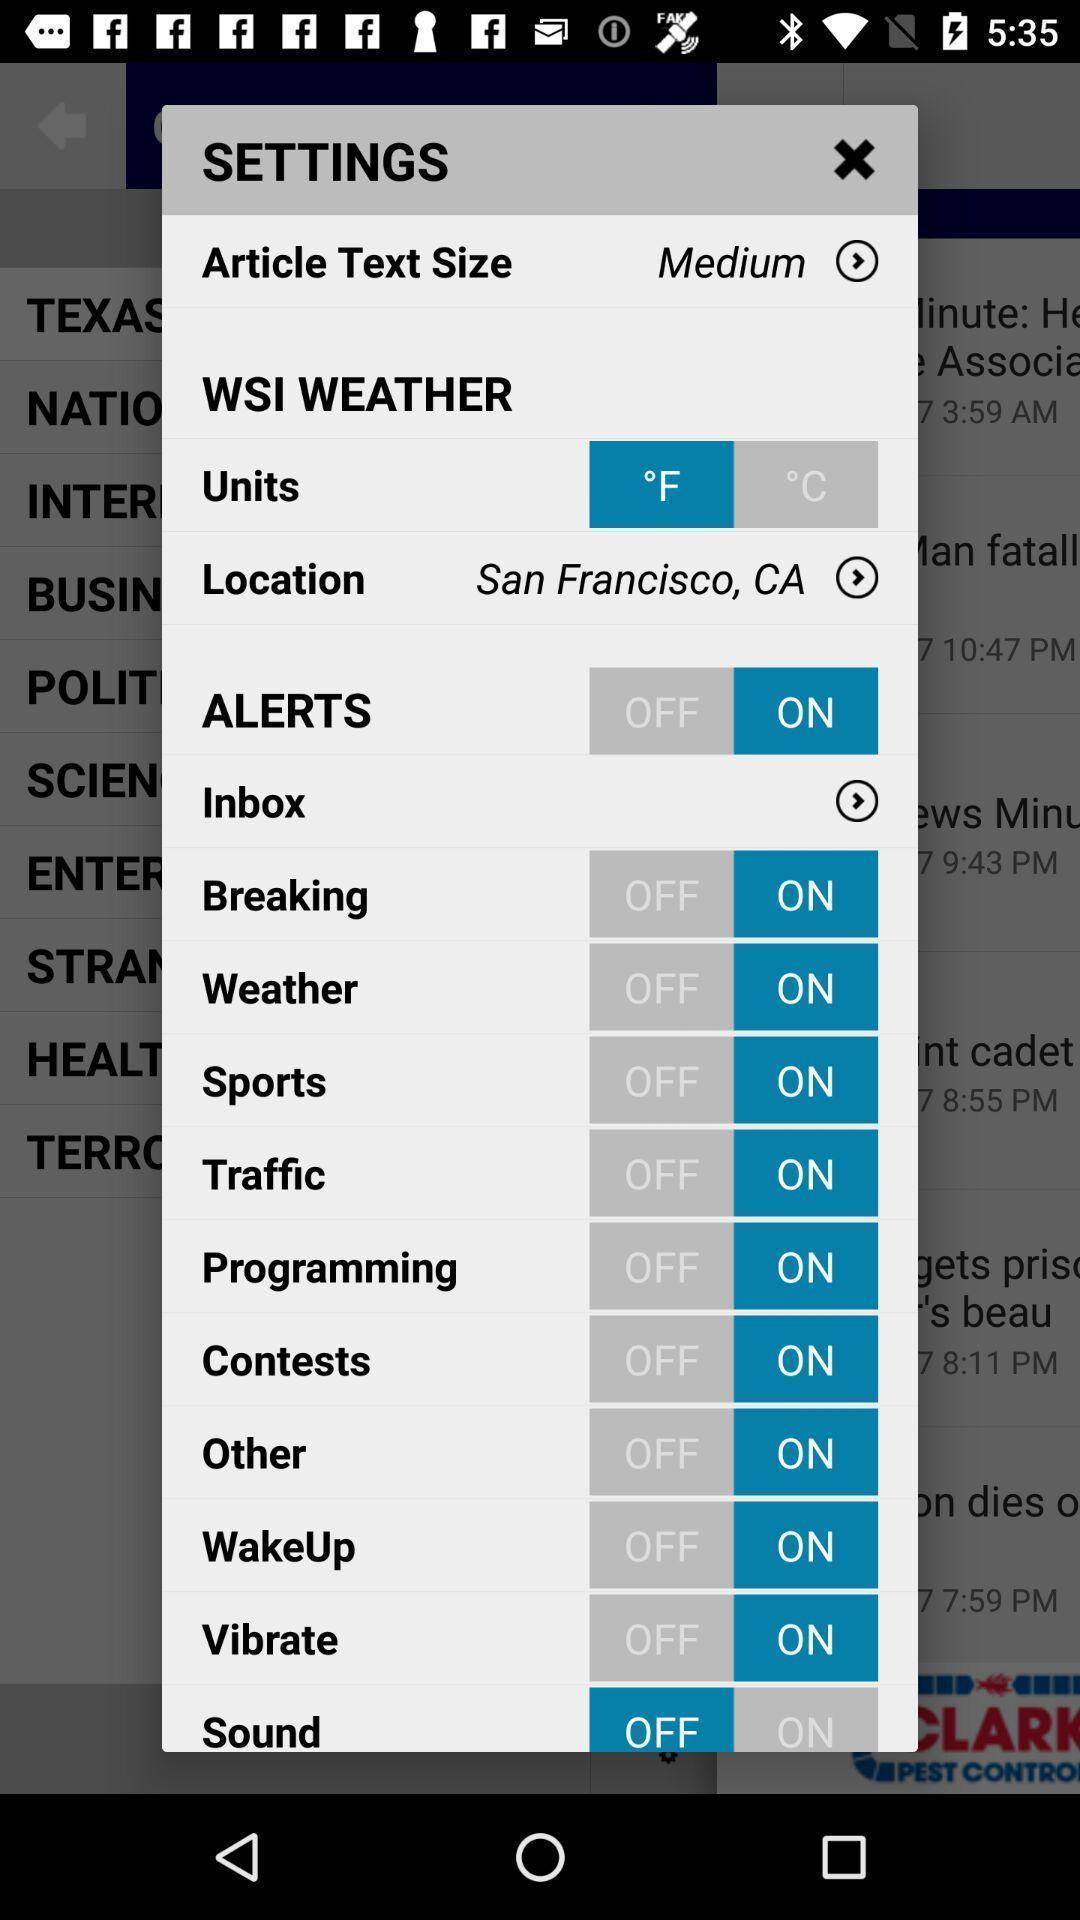Provide a textual representation of this image. Settings page with number of options to enable or disable. 